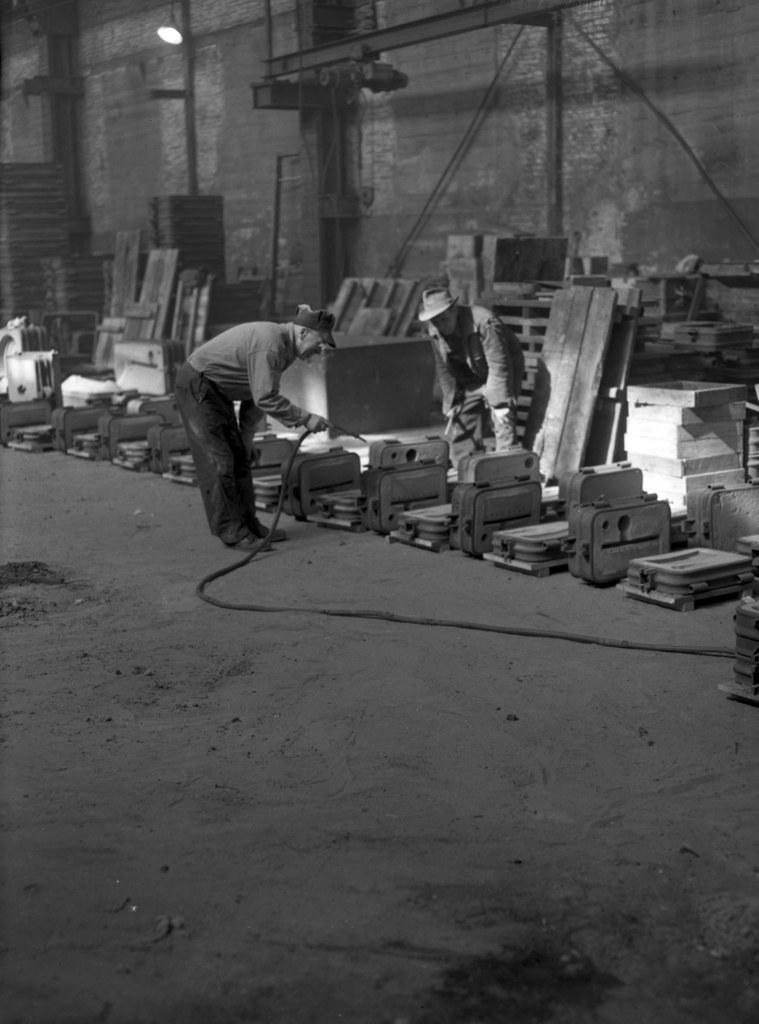What is the color scheme of the image? The image is black and white. How many persons are wearing caps in the image? There are two persons wearing caps in the image. What is one person doing in the image? One person is holding something. What can be found on the ground in the image? There are objects on the ground. What is visible in the background of the image? There is a wall in the background of the image. Where are the toys and playground located in the image? There are no toys or playground present in the image. What type of bulb is being used by the person holding something in the image? There is no bulb visible in the image; the person is holding something else. 